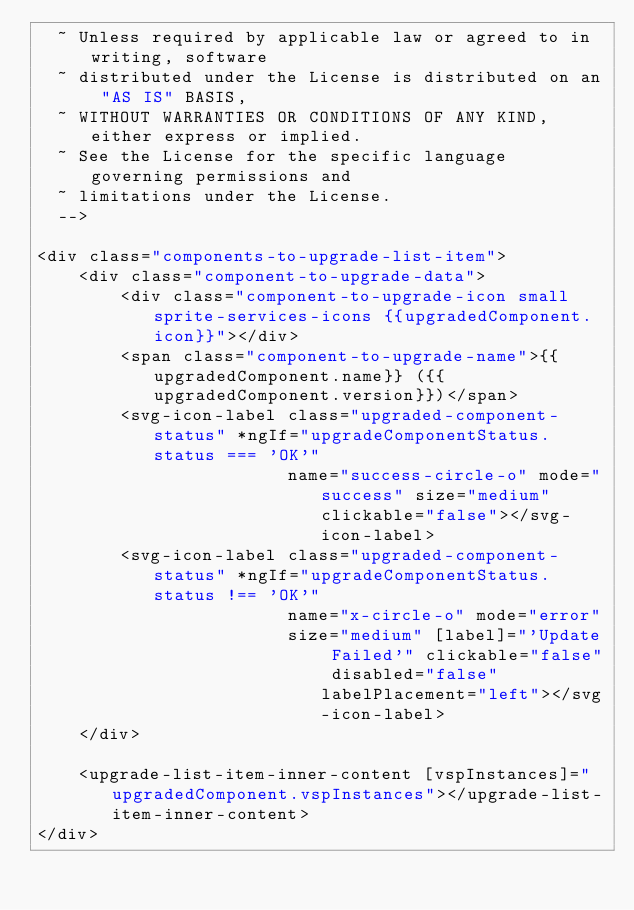<code> <loc_0><loc_0><loc_500><loc_500><_HTML_>  ~ Unless required by applicable law or agreed to in writing, software
  ~ distributed under the License is distributed on an "AS IS" BASIS,
  ~ WITHOUT WARRANTIES OR CONDITIONS OF ANY KIND, either express or implied.
  ~ See the License for the specific language governing permissions and
  ~ limitations under the License.
  -->
 
<div class="components-to-upgrade-list-item">
    <div class="component-to-upgrade-data">
        <div class="component-to-upgrade-icon small sprite-services-icons {{upgradedComponent.icon}}"></div>
        <span class="component-to-upgrade-name">{{upgradedComponent.name}} ({{upgradedComponent.version}})</span>
        <svg-icon-label class="upgraded-component-status" *ngIf="upgradeComponentStatus.status === 'OK'"
                        name="success-circle-o" mode="success" size="medium" clickable="false"></svg-icon-label>
        <svg-icon-label class="upgraded-component-status" *ngIf="upgradeComponentStatus.status !== 'OK'"
                        name="x-circle-o" mode="error"
                        size="medium" [label]="'Update Failed'" clickable="false" disabled="false" labelPlacement="left"></svg-icon-label>
    </div>

    <upgrade-list-item-inner-content [vspInstances]="upgradedComponent.vspInstances"></upgrade-list-item-inner-content>
</div></code> 